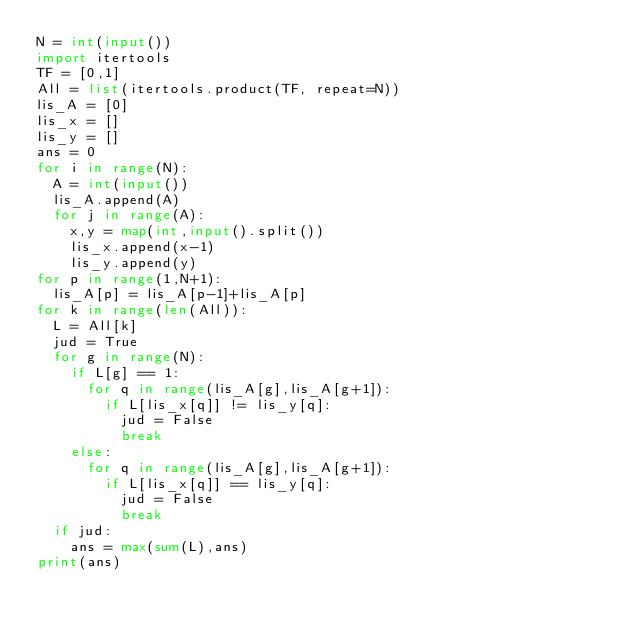Convert code to text. <code><loc_0><loc_0><loc_500><loc_500><_Python_>N = int(input())
import itertools
TF = [0,1]
All = list(itertools.product(TF, repeat=N))
lis_A = [0]
lis_x = []
lis_y = []
ans = 0
for i in range(N):
  A = int(input())
  lis_A.append(A)
  for j in range(A):
    x,y = map(int,input().split())
    lis_x.append(x-1)
    lis_y.append(y)
for p in range(1,N+1):
  lis_A[p] = lis_A[p-1]+lis_A[p]
for k in range(len(All)):
  L = All[k]
  jud = True
  for g in range(N):
    if L[g] == 1:
      for q in range(lis_A[g],lis_A[g+1]):
        if L[lis_x[q]] != lis_y[q]:
          jud = False
          break
    else:
      for q in range(lis_A[g],lis_A[g+1]):
        if L[lis_x[q]] == lis_y[q]:
          jud = False
          break
  if jud:
    ans = max(sum(L),ans)
print(ans)
</code> 